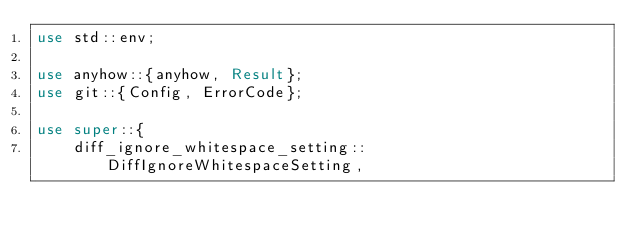Convert code to text. <code><loc_0><loc_0><loc_500><loc_500><_Rust_>use std::env;

use anyhow::{anyhow, Result};
use git::{Config, ErrorCode};

use super::{
	diff_ignore_whitespace_setting::DiffIgnoreWhitespaceSetting,</code> 